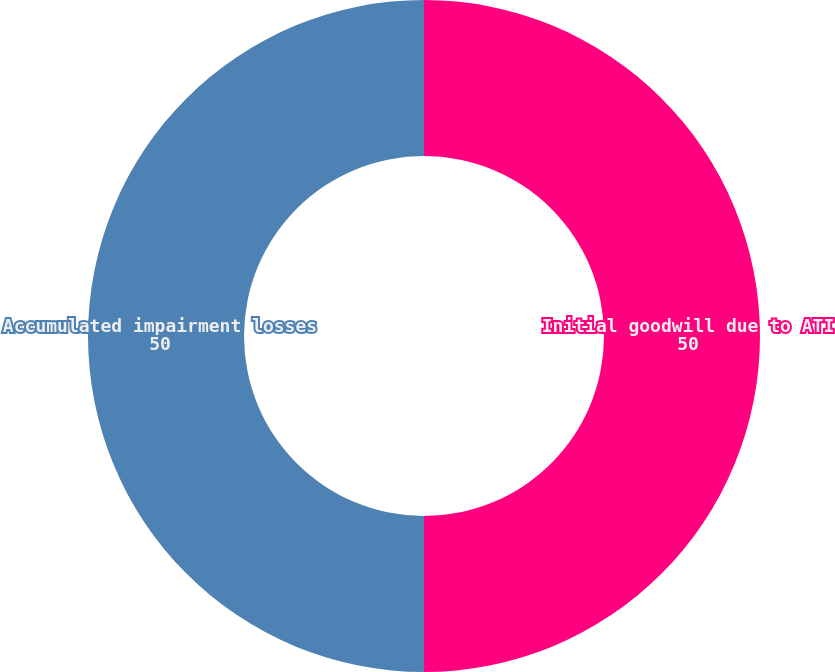Convert chart to OTSL. <chart><loc_0><loc_0><loc_500><loc_500><pie_chart><fcel>Initial goodwill due to ATI<fcel>Accumulated impairment losses<nl><fcel>50.0%<fcel>50.0%<nl></chart> 